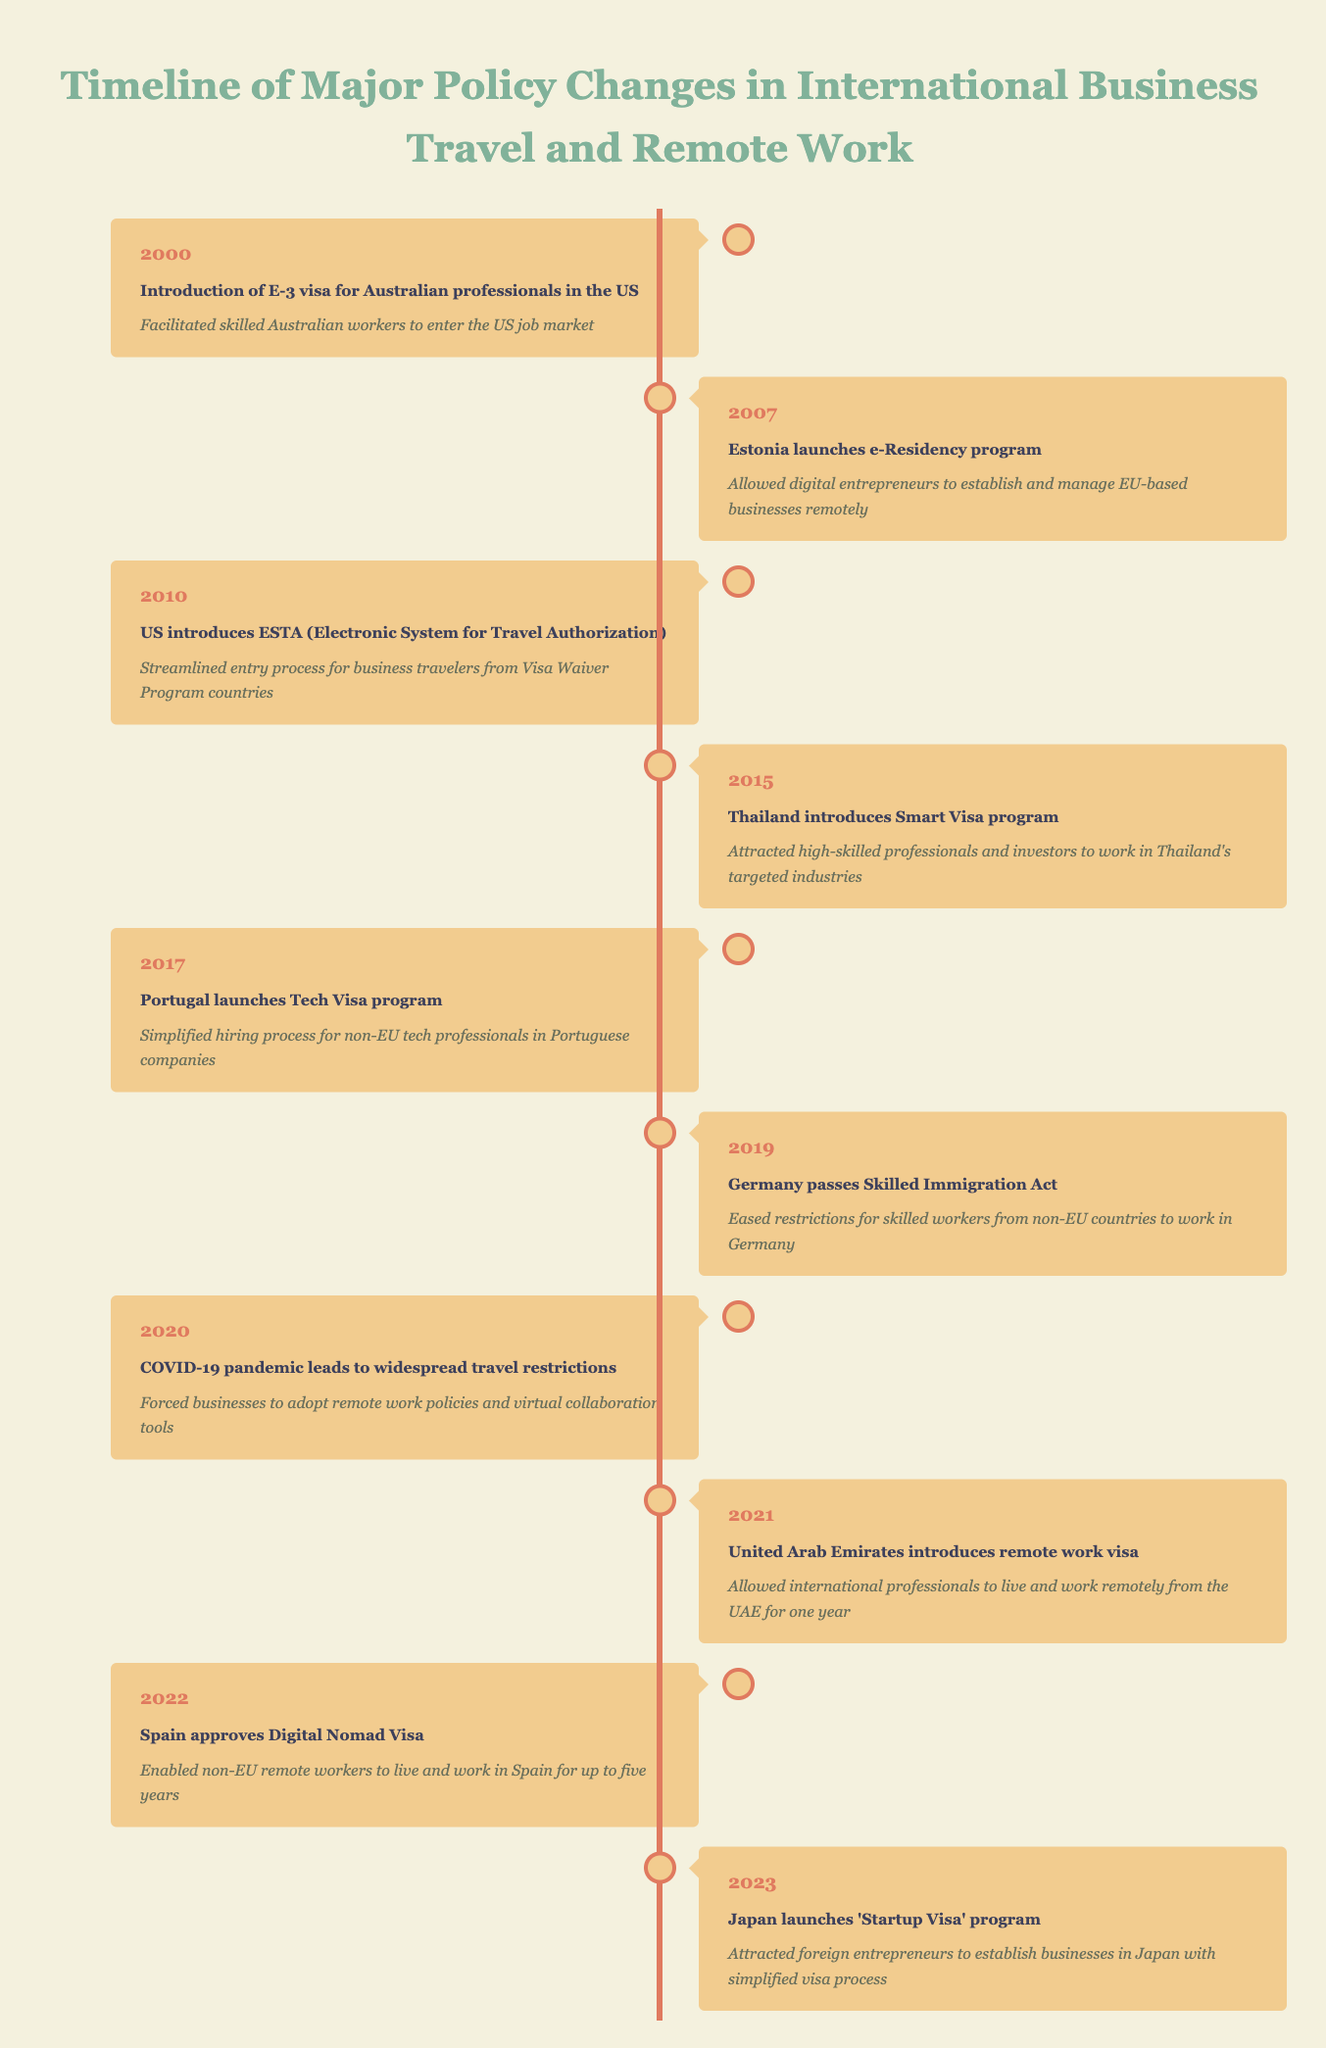What year was the introduction of the E-3 visa for Australian professionals in the US? The table lists the event "Introduction of E-3 visa for Australian professionals in the US" under the year 2000.
Answer: 2000 What impact did the introduction of the E-3 visa have? The impact stated in the table for the E-3 visa is that it "Facilitated skilled Australian workers to enter the US job market."
Answer: Facilitated skilled Australian workers to enter the US job market Which event took place in 2021? Scanning the table, the event recorded for the year 2021 is "United Arab Emirates introduces remote work visa."
Answer: United Arab Emirates introduces remote work visa How many programs were introduced after 2015? Looking at the years after 2015, the relevant events are from 2017 (Portugal’s Tech Visa), 2019 (Germany’s Skilled Immigration Act), 2021 (UAE’s remote work visa), 2022 (Spain’s Digital Nomad Visa), and 2023 (Japan’s Startup Visa). This counts as five events.
Answer: 5 Was there any significant policy change related to remote work visas before 2020? Analyzing the table, the first introduction of a remote work visa mentioned is from the UAE in 2021. Therefore, prior to 2020, no significant policy related to remote work visas was introduced.
Answer: No What are the cumulative years between the introduction of the E-3 visa and the Skilled Immigration Act in Germany? The E-3 visa was introduced in 2000 and Germany's Skilled Immigration Act was passed in 2019. Thus, calculating the difference would be 2019 - 2000 = 19 years.
Answer: 19 Did Estonia's e-Residency program allow digital entrepreneurs to manage businesses from abroad? The table specifies that Estonia's e-Residency program "Allowed digital entrepreneurs to establish and manage EU-based businesses remotely," confirming the statement.
Answer: Yes Which two events directly aimed to attract international professionals to their countries? The relevant events are "Thailand introduces Smart Visa program" in 2015 and "United Arab Emirates introduces remote work visa" in 2021 as both events aimed to attract international professionals.
Answer: 2015, 2021 How did the COVID-19 pandemic influence business travel? The table indicates that the pandemic led to "widespread travel restrictions" which forced businesses to adopt remote work policies and virtual collaboration tools, showcasing its significant influence.
Answer: Forced businesses to adopt remote work policies 